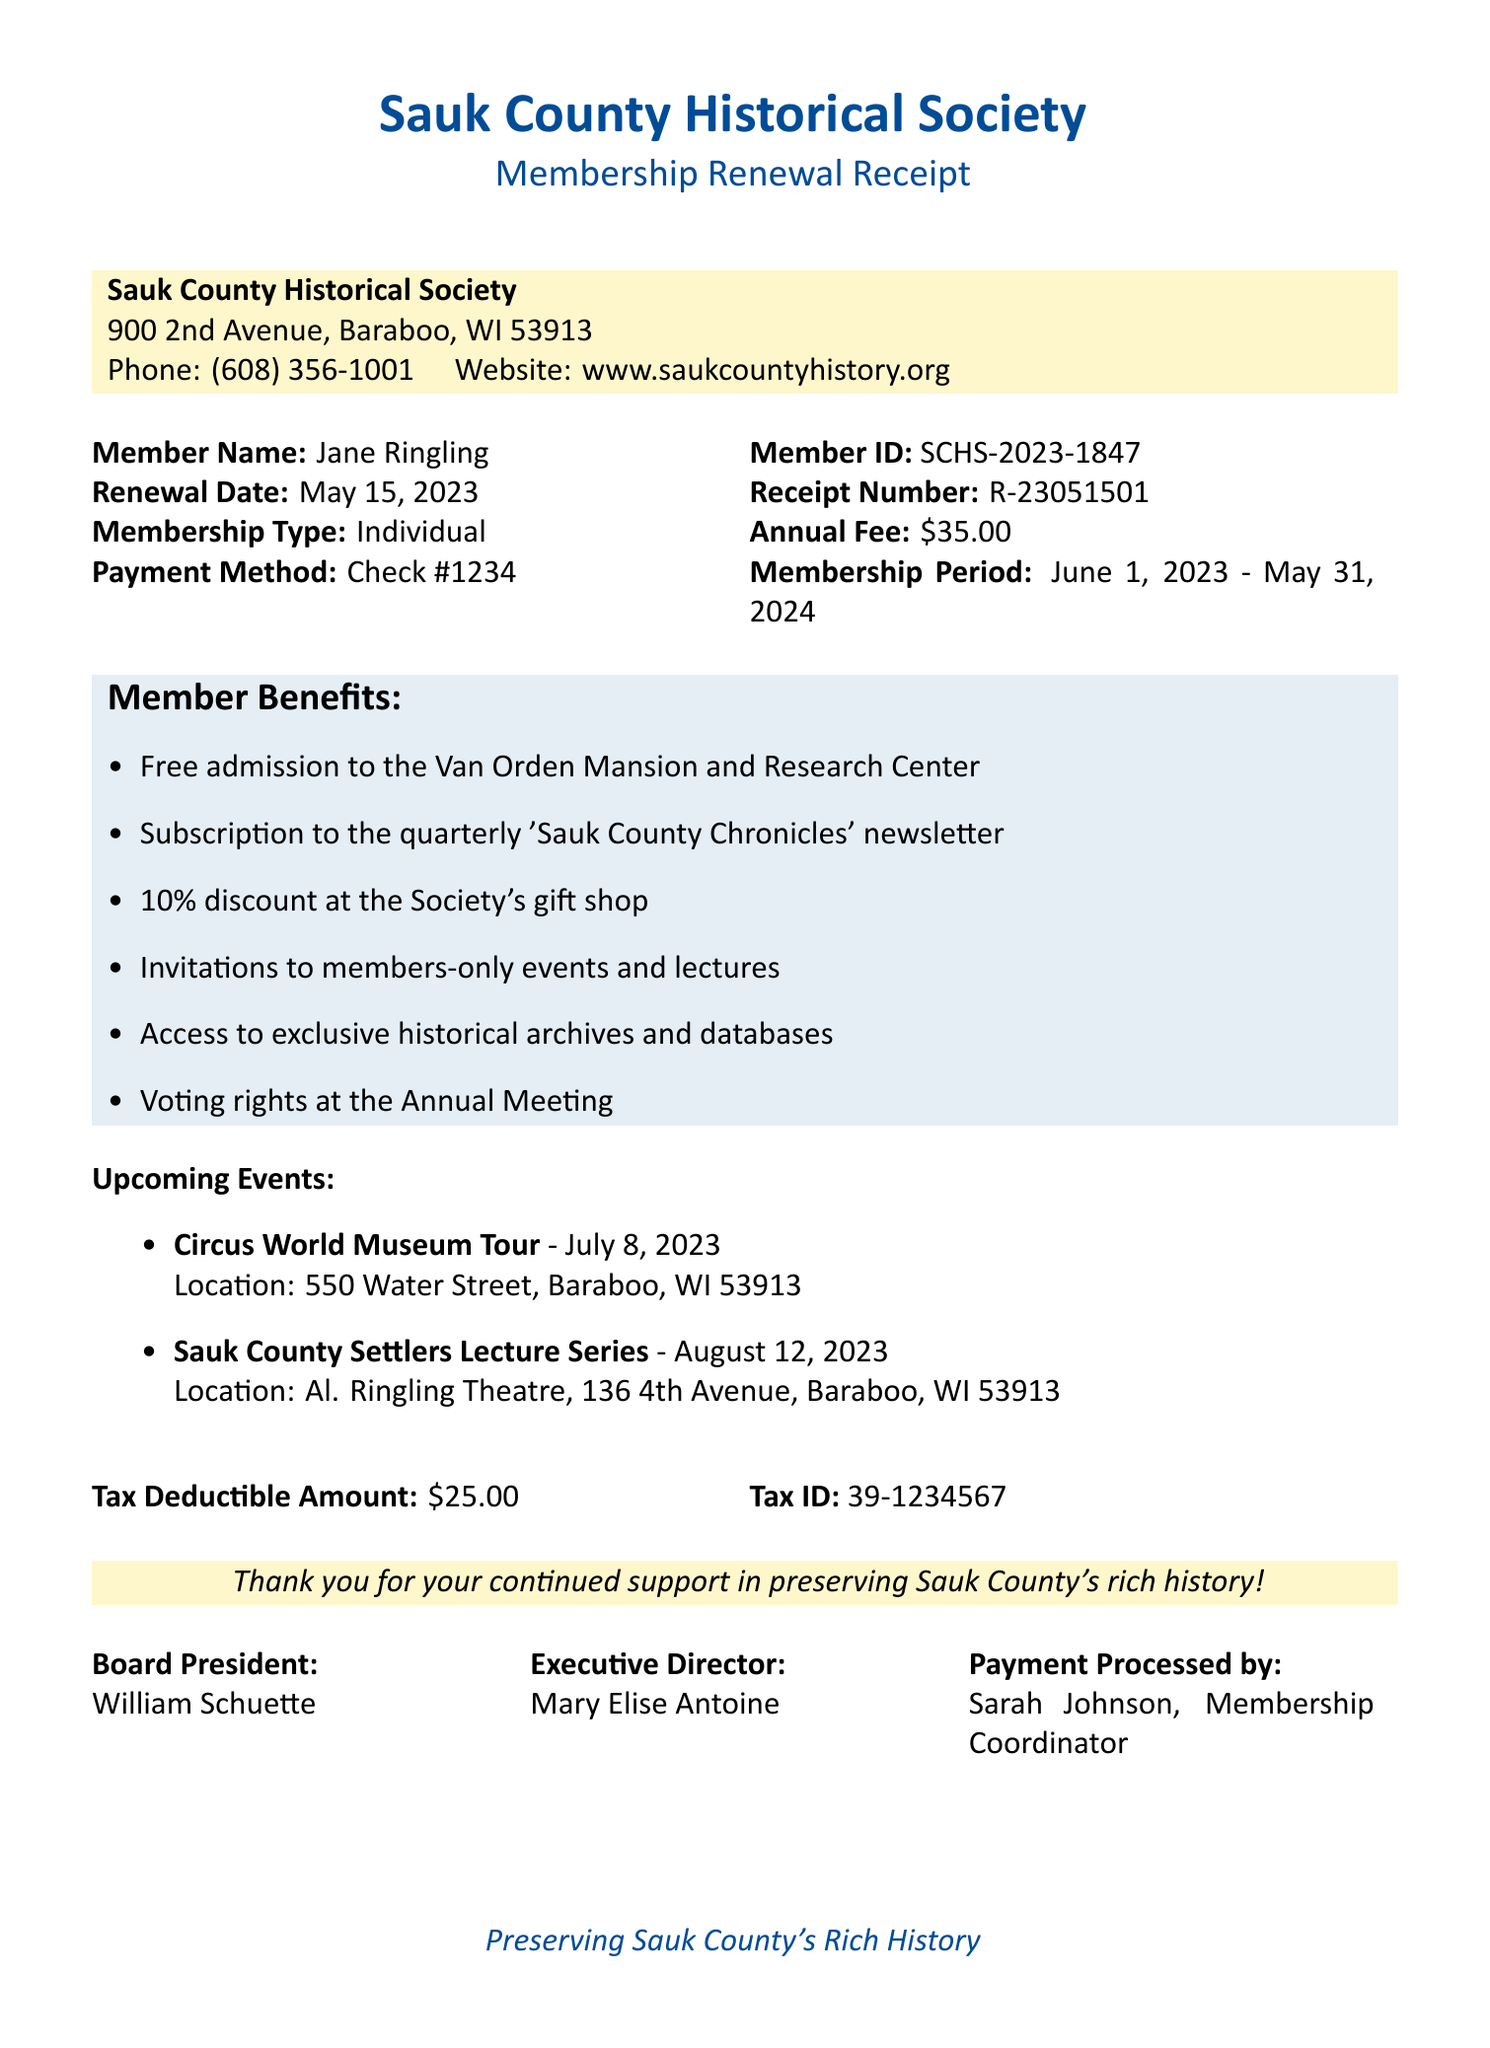what is the organization name? The organization name is indicated at the top of the document, which is the Sauk County Historical Society.
Answer: Sauk County Historical Society who is the member? The member's name is specified in the document under Member Name.
Answer: Jane Ringling what is the annual fee? The annual fee is mentioned in the financial details of the receipt.
Answer: $35.00 when does the membership period begin? The membership period details are stated in the document, indicating when it starts.
Answer: June 1, 2023 how many member benefits are listed? The number of member benefits can be counted based on the list provided in the document.
Answer: 6 what is the tax deductible amount? The tax deductible amount is specified in the financial details section.
Answer: $25.00 who processed the payment? The person who processed the payment is identified in the receipt.
Answer: Sarah Johnson, Membership Coordinator what is one of the upcoming events? The upcoming events are listed in the document, and any one of them can be selected.
Answer: Circus World Museum Tour what is the receipt number? The receipt number is stated clearly in the document under Receipt Number.
Answer: R-23051501 what is the location of the Sauk County Settlers Lecture Series? The location of the Sauk County Settlers Lecture Series is provided in the details of the event.
Answer: Al. Ringling Theatre, 136 4th Avenue, Baraboo, WI 53913 